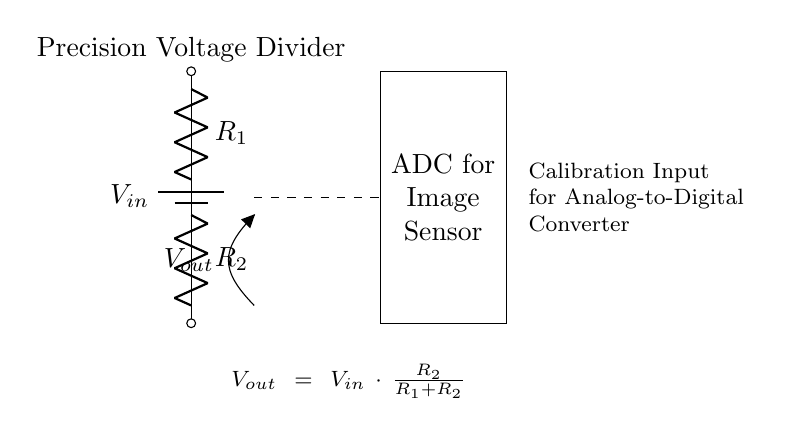What type of circuit is shown? The diagram represents a voltage divider circuit, which is used to split the voltage into smaller parts based on the resistor values.
Answer: Voltage divider What are the values of resistors used? The circuit does not provide specific numerical values for R1 and R2, so we can only identify them as R1 and R2 symbolically.
Answer: R1 and R2 What is the formula for the output voltage? The provided annotation states that the output voltage is calculated as Vout = Vin * (R2 / (R1 + R2)), where Vin is the input voltage. This directly provides the relationship between input and output in the circuit.
Answer: Vout = Vin * (R2 / (R1 + R2)) How does changing R2 affect Vout? Increasing R2 while keeping R1 constant will increase the output voltage Vout, as the ratio (R2 / (R1 + R2)) becomes larger. This relationship is critical for understanding voltage division.
Answer: Vout increases What is the purpose of the ADC in this circuit? The ADC, or Analog-to-Digital Converter, is used to convert the analog output voltage (Vout) from the voltage divider into digital values for processing in image sensor systems. This is a common application for precise calibration.
Answer: Calibration What happens if R1 is very small compared to R2? If R1 is much smaller than R2, then the output voltage Vout approaches Vin, since the ratio (R2 / (R1 + R2)) will be close to 1. This highlights the importance of resistor selection in achieving desired voltages.
Answer: Vout approaches Vin What is the effect of the precision in this voltage divider? Precision in the resistors used affects the stability and accuracy of the output voltage, which is vital for calibration in ADCs, ensuring that image data is processed correctly without error.
Answer: Increased accuracy 